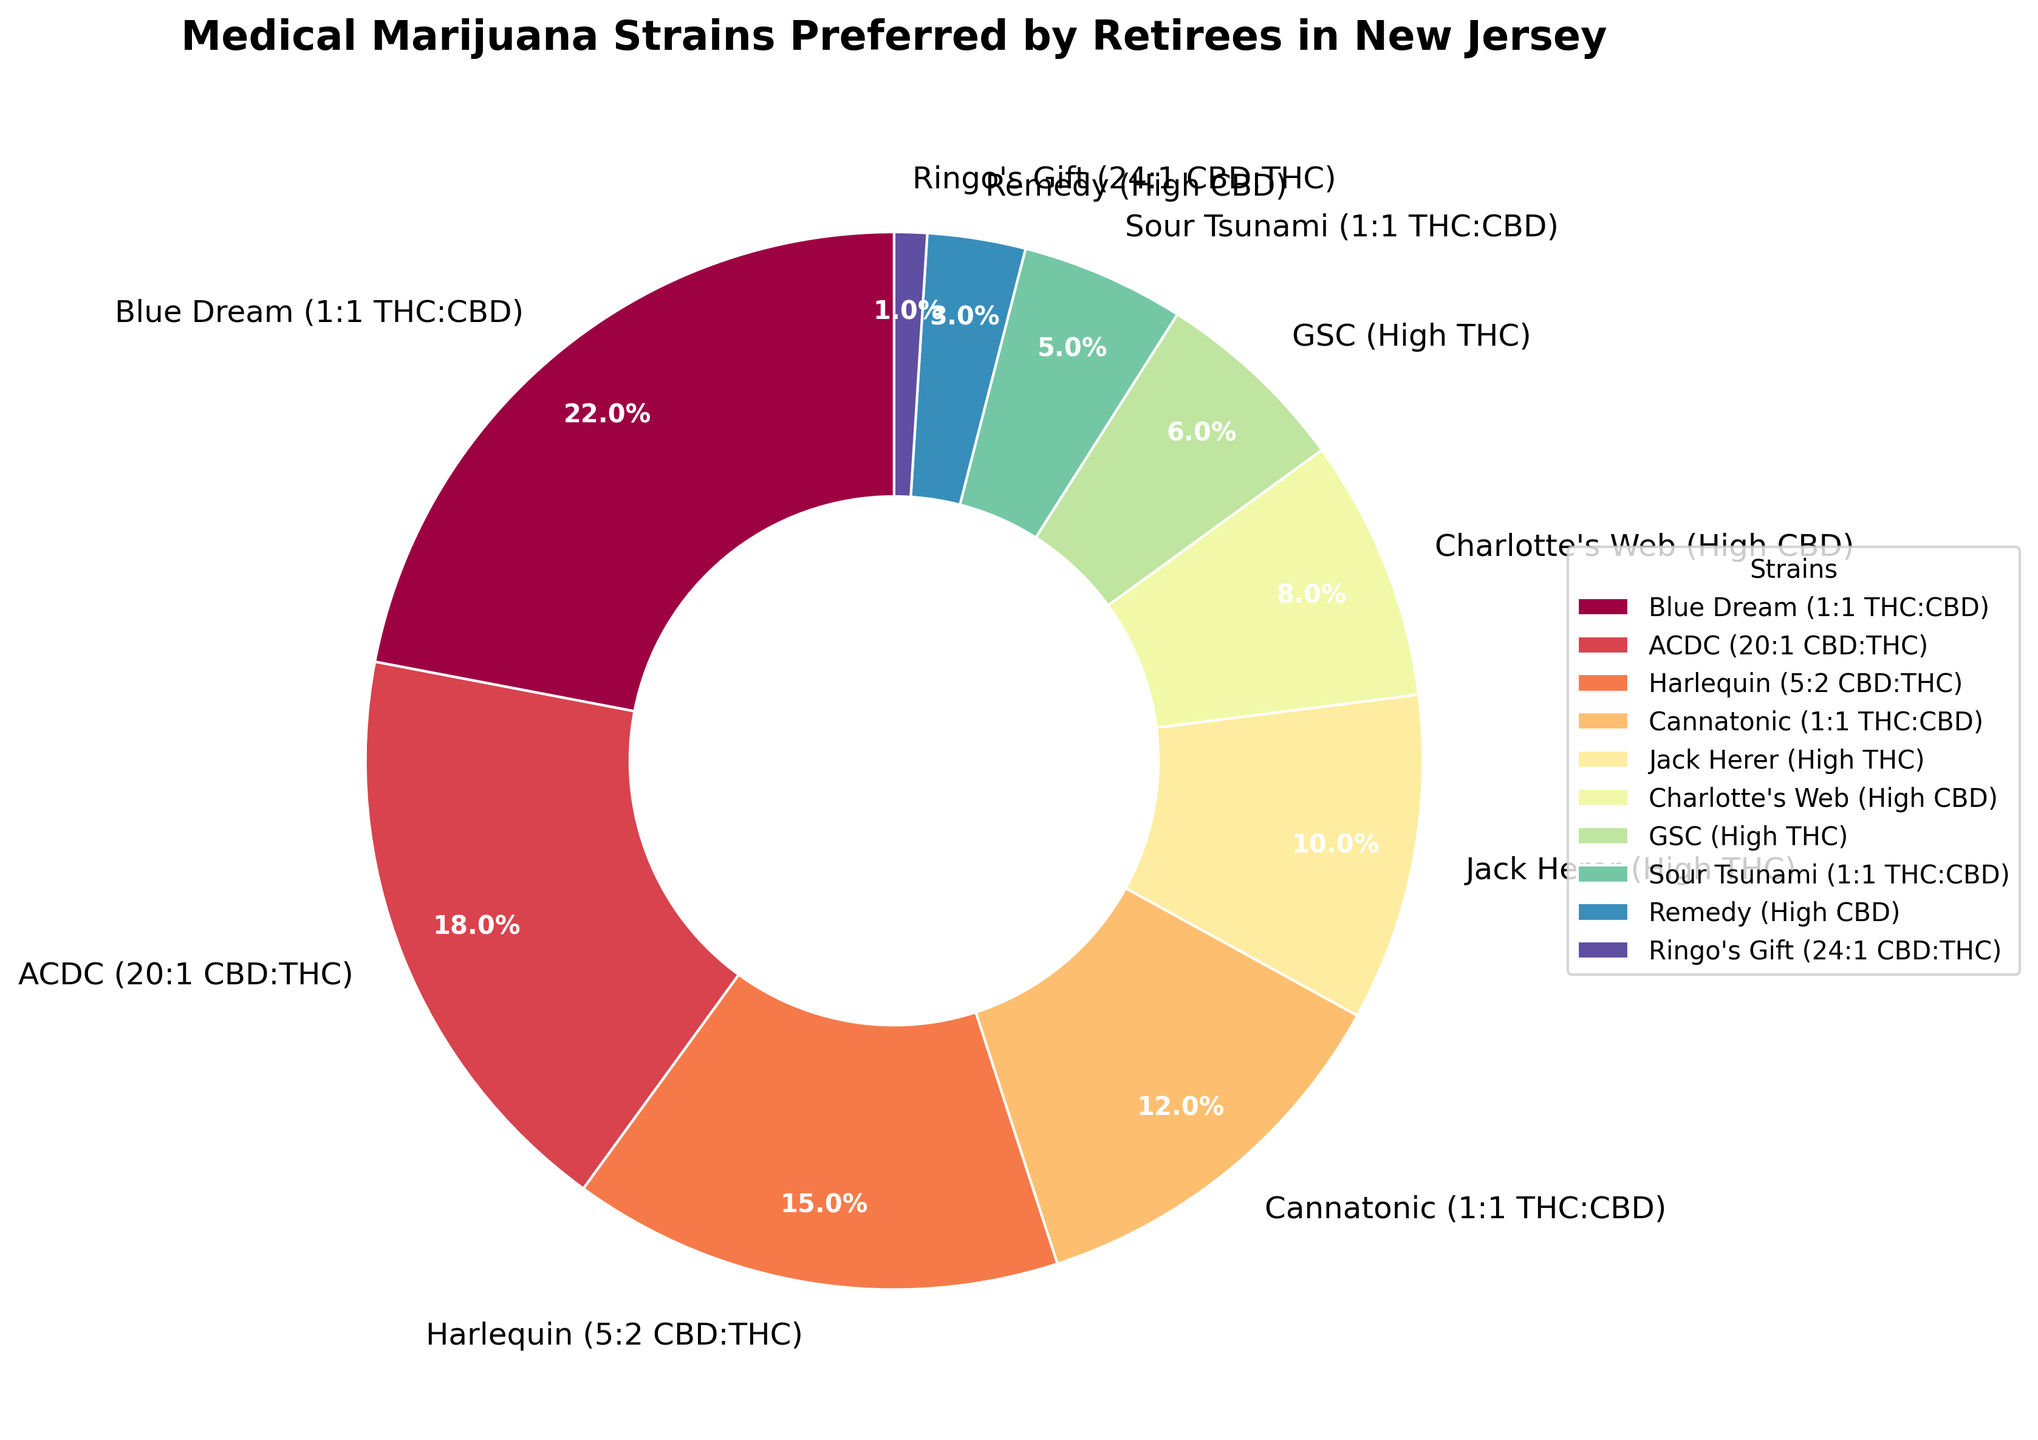What is the most preferred strain by retirees in New Jersey? The figure shows a pie chart with different percentage segments representing each strain. The largest segment in the chart represents "Blue Dream (1:1 THC:CBD)" with 22%.
Answer: Blue Dream (1:1 THC:CBD) Which strain represents 10% of preferences? According to the pie chart labels, the strain labeled "Jack Herer (High THC)" corresponds to 10% of the total preferences.
Answer: Jack Herer (High THC) How many strains have a higher percentage than "Jack Herer (High THC)"? The pie chart shows the percentage for each strain. The strains with percentages higher than "Jack Herer (High THC)" at 10% are "Blue Dream (1:1 THC:CBD)" at 22%, "ACDC (20:1 CBD:THC)" at 18%, "Harlequin (5:2 CBD:THC)" at 15%, and "Cannatonic (1:1 THC:CBD)" at 12%. So, there are four strains with higher percentages.
Answer: 4 What is the total percentage of the least preferred three strains? The least preferred three strains by percentage are "Remedy (High CBD)" at 3%, "Ringo's Gift (24:1 CBD:THC)" at 1%, and "Sour Tsunami (1:1 THC:CBD)" at 5%. Summing these percentages: 3% + 1% + 5% = 9%.
Answer: 9% Is the combined preference for strains with a 1:1 THC:CBD ratio greater than 30%? The strains with a 1:1 THC:CBD ratio are "Blue Dream (1:1 THC:CBD)" at 22%, "Cannatonic (1:1 THC:CBD)" at 12%, and "Sour Tsunami (1:1 THC:CBD)" at 5%. Adding these percentages: 22% + 12% + 5% = 39%, which is greater than 30%.
Answer: Yes Which strain is twice as preferred as "Sour Tsunami (1:1 THC:CBD)"? "Sour Tsunami (1:1 THC:CBD)" has a preference of 5%. Twice of 5% is 10%, and "Jack Herer (High THC)" is listed as having a 10% preference.
Answer: Jack Herer (High THC) Are there more high CBD preferred strains than high THC strains? According to the chart, high CBD strains are "ACDC" at 18%, "Charlotte's Web" at 8%, "Remedy" at 3%, and "Ringo's Gift" at 1% (total of 4 strains). High THC strains are "Jack Herer" at 10% and "GSC" at 6% (total of 2 strains).
Answer: Yes What is the combined percentage of strains that are either high THC or high CBD? High THC strains: "Jack Herer" (10%) and "GSC" (6%). High CBD strains: "ACDC" (18%), "Charlotte's Web" (8%), "Remedy" (3%), "Ringo's Gift" (1%). Adding these percentages together: 10% + 6% + 18% + 8% + 3% + 1% = 46%.
Answer: 46% What is the average percentage preference for strains with a CBD:THC ratio greater than 1:1? Strains with CBD:THC ratio greater than 1:1: "ACDC (20:1)" at 18%, "Harlequin (5:2)" at 15%, "Charlotte's Web" at 8%, "Remedy" at 3%, and "Ringo's Gift (24:1)" at 1%. Sum these percentages: 18% + 15% + 8% + 3% + 1% = 45%. There are 5 strains, so the average is 45% / 5 = 9%.
Answer: 9% 